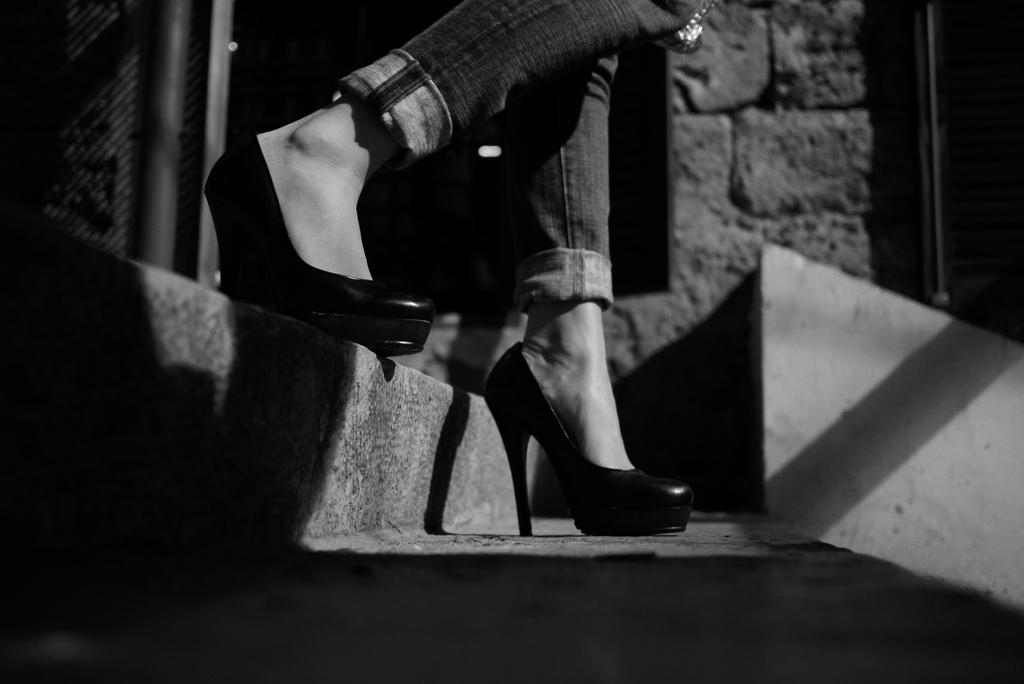What part of a person can be seen in the image? There are legs of a person in the image. What architectural feature is located on the left side of the image? There is a stair on the left side of the image. What type of background is visible in the image? There is a wall in the background of the image. What color scheme is used in the image? The image is black and white. What type of plants can be seen growing on the soda in the image? There is no soda or plants present in the image. 